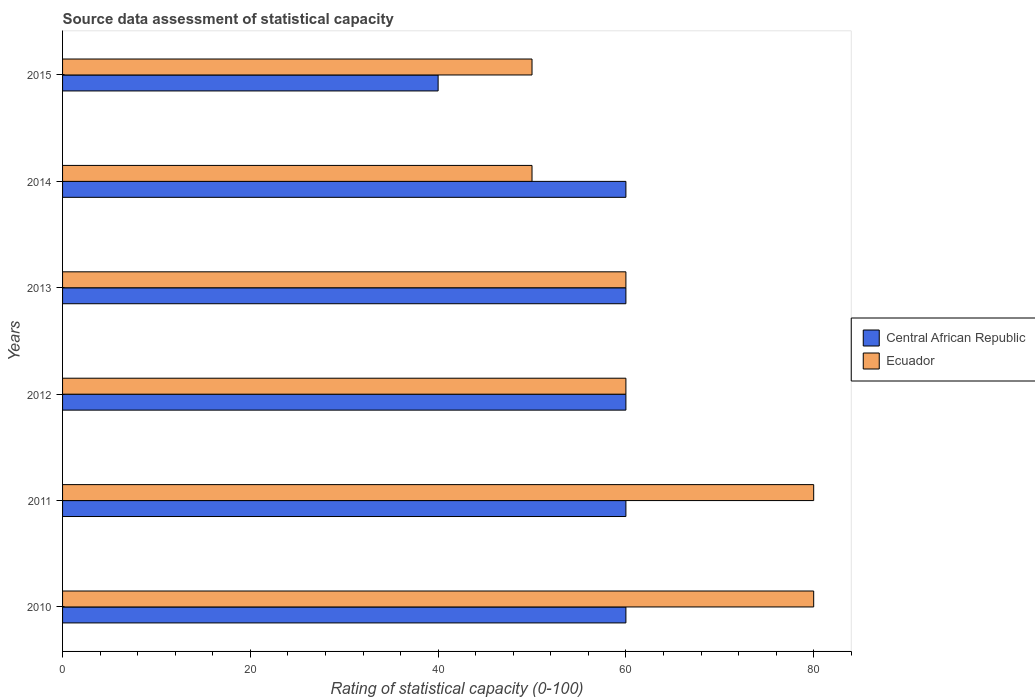How many groups of bars are there?
Ensure brevity in your answer.  6. Are the number of bars on each tick of the Y-axis equal?
Your response must be concise. Yes. What is the label of the 6th group of bars from the top?
Offer a very short reply. 2010. In how many cases, is the number of bars for a given year not equal to the number of legend labels?
Provide a succinct answer. 0. What is the rating of statistical capacity in Ecuador in 2011?
Offer a very short reply. 80. Across all years, what is the maximum rating of statistical capacity in Central African Republic?
Provide a short and direct response. 60. Across all years, what is the minimum rating of statistical capacity in Ecuador?
Your answer should be compact. 50. What is the total rating of statistical capacity in Central African Republic in the graph?
Make the answer very short. 340. What is the difference between the rating of statistical capacity in Ecuador in 2012 and that in 2013?
Your response must be concise. 0. What is the difference between the rating of statistical capacity in Ecuador in 2010 and the rating of statistical capacity in Central African Republic in 2012?
Ensure brevity in your answer.  20. What is the average rating of statistical capacity in Ecuador per year?
Provide a short and direct response. 63.33. In the year 2015, what is the difference between the rating of statistical capacity in Ecuador and rating of statistical capacity in Central African Republic?
Offer a very short reply. 10. What is the ratio of the rating of statistical capacity in Ecuador in 2012 to that in 2013?
Your answer should be very brief. 1. Is the difference between the rating of statistical capacity in Ecuador in 2012 and 2014 greater than the difference between the rating of statistical capacity in Central African Republic in 2012 and 2014?
Offer a terse response. Yes. What is the difference between the highest and the second highest rating of statistical capacity in Central African Republic?
Give a very brief answer. 0. What is the difference between the highest and the lowest rating of statistical capacity in Central African Republic?
Your answer should be very brief. 20. In how many years, is the rating of statistical capacity in Central African Republic greater than the average rating of statistical capacity in Central African Republic taken over all years?
Offer a terse response. 5. Is the sum of the rating of statistical capacity in Ecuador in 2013 and 2015 greater than the maximum rating of statistical capacity in Central African Republic across all years?
Give a very brief answer. Yes. What does the 1st bar from the top in 2013 represents?
Offer a very short reply. Ecuador. What does the 2nd bar from the bottom in 2013 represents?
Keep it short and to the point. Ecuador. Are all the bars in the graph horizontal?
Your response must be concise. Yes. How many years are there in the graph?
Your answer should be very brief. 6. What is the difference between two consecutive major ticks on the X-axis?
Make the answer very short. 20. Does the graph contain any zero values?
Give a very brief answer. No. Where does the legend appear in the graph?
Provide a succinct answer. Center right. How many legend labels are there?
Provide a short and direct response. 2. How are the legend labels stacked?
Your response must be concise. Vertical. What is the title of the graph?
Give a very brief answer. Source data assessment of statistical capacity. What is the label or title of the X-axis?
Ensure brevity in your answer.  Rating of statistical capacity (0-100). What is the label or title of the Y-axis?
Keep it short and to the point. Years. What is the Rating of statistical capacity (0-100) of Central African Republic in 2010?
Ensure brevity in your answer.  60. What is the Rating of statistical capacity (0-100) of Central African Republic in 2011?
Offer a terse response. 60. What is the Rating of statistical capacity (0-100) of Ecuador in 2011?
Ensure brevity in your answer.  80. What is the Rating of statistical capacity (0-100) in Ecuador in 2013?
Provide a succinct answer. 60. What is the Rating of statistical capacity (0-100) of Central African Republic in 2014?
Your answer should be very brief. 60. What is the Rating of statistical capacity (0-100) of Ecuador in 2014?
Make the answer very short. 50. What is the Rating of statistical capacity (0-100) in Central African Republic in 2015?
Your answer should be compact. 40. Across all years, what is the maximum Rating of statistical capacity (0-100) in Ecuador?
Provide a short and direct response. 80. What is the total Rating of statistical capacity (0-100) of Central African Republic in the graph?
Offer a terse response. 340. What is the total Rating of statistical capacity (0-100) of Ecuador in the graph?
Provide a short and direct response. 380. What is the difference between the Rating of statistical capacity (0-100) of Ecuador in 2010 and that in 2011?
Make the answer very short. 0. What is the difference between the Rating of statistical capacity (0-100) of Central African Republic in 2010 and that in 2012?
Offer a terse response. 0. What is the difference between the Rating of statistical capacity (0-100) in Ecuador in 2010 and that in 2012?
Ensure brevity in your answer.  20. What is the difference between the Rating of statistical capacity (0-100) in Central African Republic in 2010 and that in 2014?
Provide a short and direct response. 0. What is the difference between the Rating of statistical capacity (0-100) of Central African Republic in 2011 and that in 2012?
Provide a succinct answer. 0. What is the difference between the Rating of statistical capacity (0-100) in Ecuador in 2011 and that in 2012?
Keep it short and to the point. 20. What is the difference between the Rating of statistical capacity (0-100) in Central African Republic in 2012 and that in 2013?
Your answer should be compact. 0. What is the difference between the Rating of statistical capacity (0-100) of Central African Republic in 2012 and that in 2014?
Your answer should be compact. 0. What is the difference between the Rating of statistical capacity (0-100) of Ecuador in 2012 and that in 2014?
Offer a very short reply. 10. What is the difference between the Rating of statistical capacity (0-100) in Central African Republic in 2012 and that in 2015?
Keep it short and to the point. 20. What is the difference between the Rating of statistical capacity (0-100) in Ecuador in 2012 and that in 2015?
Give a very brief answer. 10. What is the difference between the Rating of statistical capacity (0-100) of Central African Republic in 2013 and that in 2014?
Ensure brevity in your answer.  0. What is the difference between the Rating of statistical capacity (0-100) of Ecuador in 2013 and that in 2014?
Provide a short and direct response. 10. What is the difference between the Rating of statistical capacity (0-100) of Central African Republic in 2013 and that in 2015?
Provide a short and direct response. 20. What is the difference between the Rating of statistical capacity (0-100) in Ecuador in 2013 and that in 2015?
Keep it short and to the point. 10. What is the difference between the Rating of statistical capacity (0-100) in Central African Republic in 2014 and that in 2015?
Provide a succinct answer. 20. What is the difference between the Rating of statistical capacity (0-100) in Central African Republic in 2010 and the Rating of statistical capacity (0-100) in Ecuador in 2011?
Keep it short and to the point. -20. What is the difference between the Rating of statistical capacity (0-100) of Central African Republic in 2010 and the Rating of statistical capacity (0-100) of Ecuador in 2012?
Provide a short and direct response. 0. What is the difference between the Rating of statistical capacity (0-100) of Central African Republic in 2010 and the Rating of statistical capacity (0-100) of Ecuador in 2013?
Give a very brief answer. 0. What is the difference between the Rating of statistical capacity (0-100) of Central African Republic in 2011 and the Rating of statistical capacity (0-100) of Ecuador in 2012?
Your response must be concise. 0. What is the difference between the Rating of statistical capacity (0-100) of Central African Republic in 2011 and the Rating of statistical capacity (0-100) of Ecuador in 2014?
Your answer should be very brief. 10. What is the difference between the Rating of statistical capacity (0-100) in Central African Republic in 2011 and the Rating of statistical capacity (0-100) in Ecuador in 2015?
Make the answer very short. 10. What is the difference between the Rating of statistical capacity (0-100) in Central African Republic in 2013 and the Rating of statistical capacity (0-100) in Ecuador in 2014?
Keep it short and to the point. 10. What is the difference between the Rating of statistical capacity (0-100) of Central African Republic in 2014 and the Rating of statistical capacity (0-100) of Ecuador in 2015?
Your answer should be very brief. 10. What is the average Rating of statistical capacity (0-100) of Central African Republic per year?
Ensure brevity in your answer.  56.67. What is the average Rating of statistical capacity (0-100) of Ecuador per year?
Make the answer very short. 63.33. In the year 2011, what is the difference between the Rating of statistical capacity (0-100) of Central African Republic and Rating of statistical capacity (0-100) of Ecuador?
Your answer should be compact. -20. In the year 2013, what is the difference between the Rating of statistical capacity (0-100) in Central African Republic and Rating of statistical capacity (0-100) in Ecuador?
Provide a succinct answer. 0. In the year 2014, what is the difference between the Rating of statistical capacity (0-100) in Central African Republic and Rating of statistical capacity (0-100) in Ecuador?
Provide a short and direct response. 10. What is the ratio of the Rating of statistical capacity (0-100) in Central African Republic in 2010 to that in 2011?
Ensure brevity in your answer.  1. What is the ratio of the Rating of statistical capacity (0-100) in Ecuador in 2010 to that in 2012?
Provide a succinct answer. 1.33. What is the ratio of the Rating of statistical capacity (0-100) of Central African Republic in 2010 to that in 2014?
Give a very brief answer. 1. What is the ratio of the Rating of statistical capacity (0-100) in Ecuador in 2010 to that in 2014?
Provide a succinct answer. 1.6. What is the ratio of the Rating of statistical capacity (0-100) in Central African Republic in 2011 to that in 2014?
Make the answer very short. 1. What is the ratio of the Rating of statistical capacity (0-100) of Ecuador in 2012 to that in 2013?
Make the answer very short. 1. What is the ratio of the Rating of statistical capacity (0-100) of Central African Republic in 2012 to that in 2014?
Your answer should be very brief. 1. What is the ratio of the Rating of statistical capacity (0-100) in Central African Republic in 2012 to that in 2015?
Provide a short and direct response. 1.5. What is the ratio of the Rating of statistical capacity (0-100) in Ecuador in 2012 to that in 2015?
Ensure brevity in your answer.  1.2. What is the ratio of the Rating of statistical capacity (0-100) in Central African Republic in 2013 to that in 2015?
Offer a very short reply. 1.5. What is the ratio of the Rating of statistical capacity (0-100) of Ecuador in 2013 to that in 2015?
Provide a succinct answer. 1.2. What is the ratio of the Rating of statistical capacity (0-100) of Ecuador in 2014 to that in 2015?
Give a very brief answer. 1. What is the difference between the highest and the lowest Rating of statistical capacity (0-100) of Ecuador?
Your answer should be very brief. 30. 